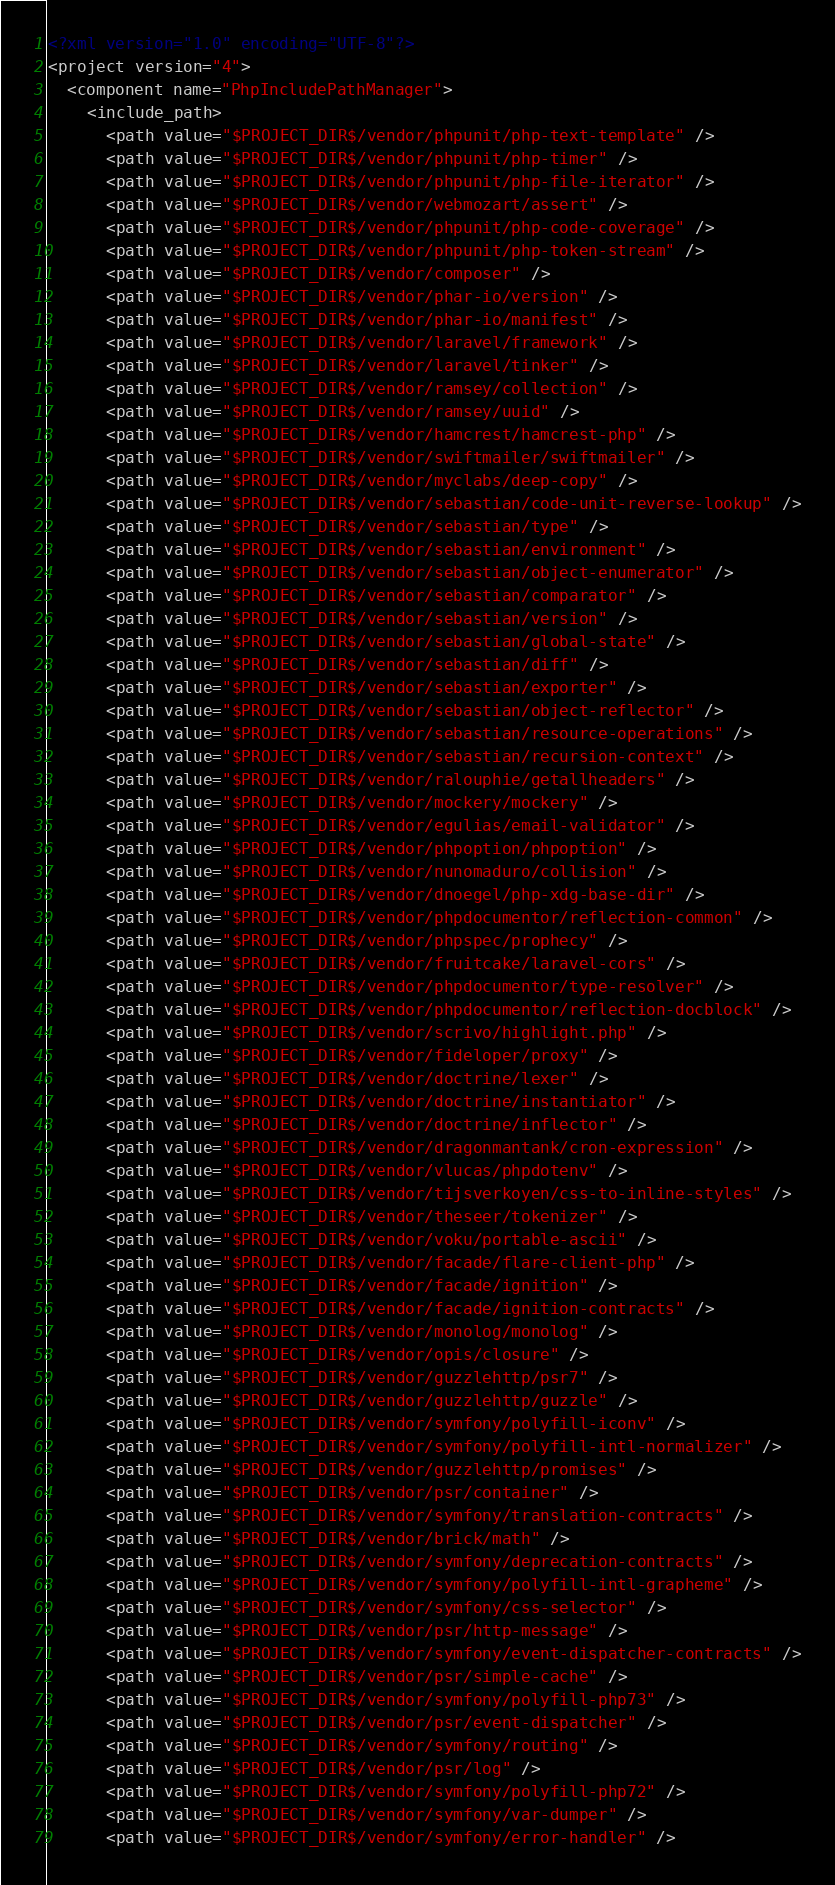<code> <loc_0><loc_0><loc_500><loc_500><_XML_><?xml version="1.0" encoding="UTF-8"?>
<project version="4">
  <component name="PhpIncludePathManager">
    <include_path>
      <path value="$PROJECT_DIR$/vendor/phpunit/php-text-template" />
      <path value="$PROJECT_DIR$/vendor/phpunit/php-timer" />
      <path value="$PROJECT_DIR$/vendor/phpunit/php-file-iterator" />
      <path value="$PROJECT_DIR$/vendor/webmozart/assert" />
      <path value="$PROJECT_DIR$/vendor/phpunit/php-code-coverage" />
      <path value="$PROJECT_DIR$/vendor/phpunit/php-token-stream" />
      <path value="$PROJECT_DIR$/vendor/composer" />
      <path value="$PROJECT_DIR$/vendor/phar-io/version" />
      <path value="$PROJECT_DIR$/vendor/phar-io/manifest" />
      <path value="$PROJECT_DIR$/vendor/laravel/framework" />
      <path value="$PROJECT_DIR$/vendor/laravel/tinker" />
      <path value="$PROJECT_DIR$/vendor/ramsey/collection" />
      <path value="$PROJECT_DIR$/vendor/ramsey/uuid" />
      <path value="$PROJECT_DIR$/vendor/hamcrest/hamcrest-php" />
      <path value="$PROJECT_DIR$/vendor/swiftmailer/swiftmailer" />
      <path value="$PROJECT_DIR$/vendor/myclabs/deep-copy" />
      <path value="$PROJECT_DIR$/vendor/sebastian/code-unit-reverse-lookup" />
      <path value="$PROJECT_DIR$/vendor/sebastian/type" />
      <path value="$PROJECT_DIR$/vendor/sebastian/environment" />
      <path value="$PROJECT_DIR$/vendor/sebastian/object-enumerator" />
      <path value="$PROJECT_DIR$/vendor/sebastian/comparator" />
      <path value="$PROJECT_DIR$/vendor/sebastian/version" />
      <path value="$PROJECT_DIR$/vendor/sebastian/global-state" />
      <path value="$PROJECT_DIR$/vendor/sebastian/diff" />
      <path value="$PROJECT_DIR$/vendor/sebastian/exporter" />
      <path value="$PROJECT_DIR$/vendor/sebastian/object-reflector" />
      <path value="$PROJECT_DIR$/vendor/sebastian/resource-operations" />
      <path value="$PROJECT_DIR$/vendor/sebastian/recursion-context" />
      <path value="$PROJECT_DIR$/vendor/ralouphie/getallheaders" />
      <path value="$PROJECT_DIR$/vendor/mockery/mockery" />
      <path value="$PROJECT_DIR$/vendor/egulias/email-validator" />
      <path value="$PROJECT_DIR$/vendor/phpoption/phpoption" />
      <path value="$PROJECT_DIR$/vendor/nunomaduro/collision" />
      <path value="$PROJECT_DIR$/vendor/dnoegel/php-xdg-base-dir" />
      <path value="$PROJECT_DIR$/vendor/phpdocumentor/reflection-common" />
      <path value="$PROJECT_DIR$/vendor/phpspec/prophecy" />
      <path value="$PROJECT_DIR$/vendor/fruitcake/laravel-cors" />
      <path value="$PROJECT_DIR$/vendor/phpdocumentor/type-resolver" />
      <path value="$PROJECT_DIR$/vendor/phpdocumentor/reflection-docblock" />
      <path value="$PROJECT_DIR$/vendor/scrivo/highlight.php" />
      <path value="$PROJECT_DIR$/vendor/fideloper/proxy" />
      <path value="$PROJECT_DIR$/vendor/doctrine/lexer" />
      <path value="$PROJECT_DIR$/vendor/doctrine/instantiator" />
      <path value="$PROJECT_DIR$/vendor/doctrine/inflector" />
      <path value="$PROJECT_DIR$/vendor/dragonmantank/cron-expression" />
      <path value="$PROJECT_DIR$/vendor/vlucas/phpdotenv" />
      <path value="$PROJECT_DIR$/vendor/tijsverkoyen/css-to-inline-styles" />
      <path value="$PROJECT_DIR$/vendor/theseer/tokenizer" />
      <path value="$PROJECT_DIR$/vendor/voku/portable-ascii" />
      <path value="$PROJECT_DIR$/vendor/facade/flare-client-php" />
      <path value="$PROJECT_DIR$/vendor/facade/ignition" />
      <path value="$PROJECT_DIR$/vendor/facade/ignition-contracts" />
      <path value="$PROJECT_DIR$/vendor/monolog/monolog" />
      <path value="$PROJECT_DIR$/vendor/opis/closure" />
      <path value="$PROJECT_DIR$/vendor/guzzlehttp/psr7" />
      <path value="$PROJECT_DIR$/vendor/guzzlehttp/guzzle" />
      <path value="$PROJECT_DIR$/vendor/symfony/polyfill-iconv" />
      <path value="$PROJECT_DIR$/vendor/symfony/polyfill-intl-normalizer" />
      <path value="$PROJECT_DIR$/vendor/guzzlehttp/promises" />
      <path value="$PROJECT_DIR$/vendor/psr/container" />
      <path value="$PROJECT_DIR$/vendor/symfony/translation-contracts" />
      <path value="$PROJECT_DIR$/vendor/brick/math" />
      <path value="$PROJECT_DIR$/vendor/symfony/deprecation-contracts" />
      <path value="$PROJECT_DIR$/vendor/symfony/polyfill-intl-grapheme" />
      <path value="$PROJECT_DIR$/vendor/symfony/css-selector" />
      <path value="$PROJECT_DIR$/vendor/psr/http-message" />
      <path value="$PROJECT_DIR$/vendor/symfony/event-dispatcher-contracts" />
      <path value="$PROJECT_DIR$/vendor/psr/simple-cache" />
      <path value="$PROJECT_DIR$/vendor/symfony/polyfill-php73" />
      <path value="$PROJECT_DIR$/vendor/psr/event-dispatcher" />
      <path value="$PROJECT_DIR$/vendor/symfony/routing" />
      <path value="$PROJECT_DIR$/vendor/psr/log" />
      <path value="$PROJECT_DIR$/vendor/symfony/polyfill-php72" />
      <path value="$PROJECT_DIR$/vendor/symfony/var-dumper" />
      <path value="$PROJECT_DIR$/vendor/symfony/error-handler" /></code> 